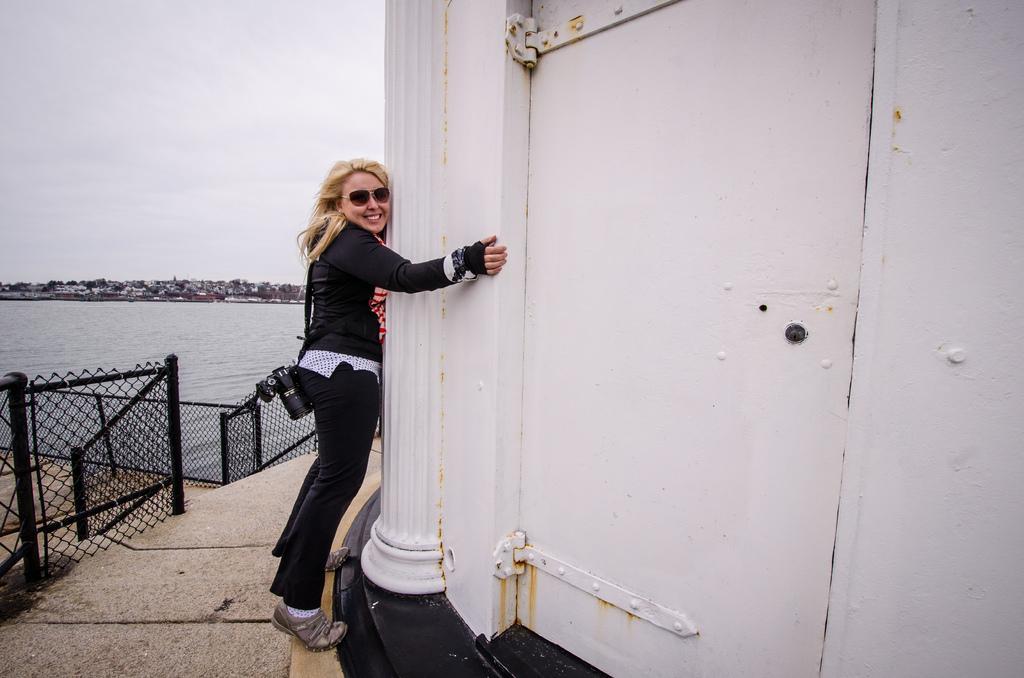Describe this image in one or two sentences. This image is taken outdoors. At the bottom of the image there is a floor. On the right side of the image there is a building with a wall, a pillar and a door. In the middle of the image a woman is standing on the floor and she is holding a pillar. On the left side of the image there is a fencing and there is a pond. At the top of the image there is a sky with clouds. 